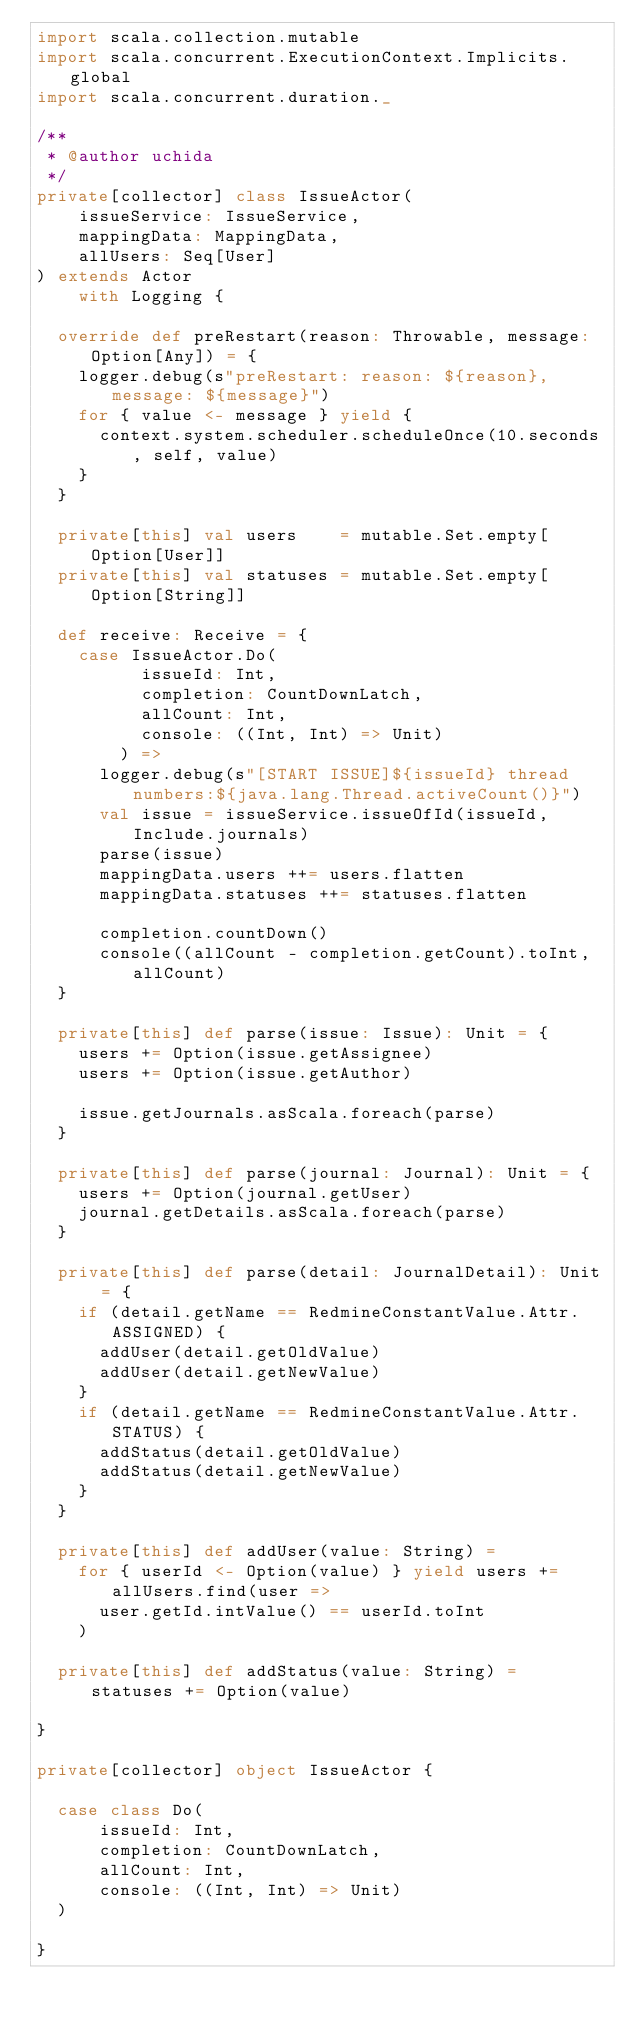Convert code to text. <code><loc_0><loc_0><loc_500><loc_500><_Scala_>import scala.collection.mutable
import scala.concurrent.ExecutionContext.Implicits.global
import scala.concurrent.duration._

/**
 * @author uchida
 */
private[collector] class IssueActor(
    issueService: IssueService,
    mappingData: MappingData,
    allUsers: Seq[User]
) extends Actor
    with Logging {

  override def preRestart(reason: Throwable, message: Option[Any]) = {
    logger.debug(s"preRestart: reason: ${reason}, message: ${message}")
    for { value <- message } yield {
      context.system.scheduler.scheduleOnce(10.seconds, self, value)
    }
  }

  private[this] val users    = mutable.Set.empty[Option[User]]
  private[this] val statuses = mutable.Set.empty[Option[String]]

  def receive: Receive = {
    case IssueActor.Do(
          issueId: Int,
          completion: CountDownLatch,
          allCount: Int,
          console: ((Int, Int) => Unit)
        ) =>
      logger.debug(s"[START ISSUE]${issueId} thread numbers:${java.lang.Thread.activeCount()}")
      val issue = issueService.issueOfId(issueId, Include.journals)
      parse(issue)
      mappingData.users ++= users.flatten
      mappingData.statuses ++= statuses.flatten

      completion.countDown()
      console((allCount - completion.getCount).toInt, allCount)
  }

  private[this] def parse(issue: Issue): Unit = {
    users += Option(issue.getAssignee)
    users += Option(issue.getAuthor)

    issue.getJournals.asScala.foreach(parse)
  }

  private[this] def parse(journal: Journal): Unit = {
    users += Option(journal.getUser)
    journal.getDetails.asScala.foreach(parse)
  }

  private[this] def parse(detail: JournalDetail): Unit = {
    if (detail.getName == RedmineConstantValue.Attr.ASSIGNED) {
      addUser(detail.getOldValue)
      addUser(detail.getNewValue)
    }
    if (detail.getName == RedmineConstantValue.Attr.STATUS) {
      addStatus(detail.getOldValue)
      addStatus(detail.getNewValue)
    }
  }

  private[this] def addUser(value: String) =
    for { userId <- Option(value) } yield users += allUsers.find(user =>
      user.getId.intValue() == userId.toInt
    )

  private[this] def addStatus(value: String) = statuses += Option(value)

}

private[collector] object IssueActor {

  case class Do(
      issueId: Int,
      completion: CountDownLatch,
      allCount: Int,
      console: ((Int, Int) => Unit)
  )

}
</code> 